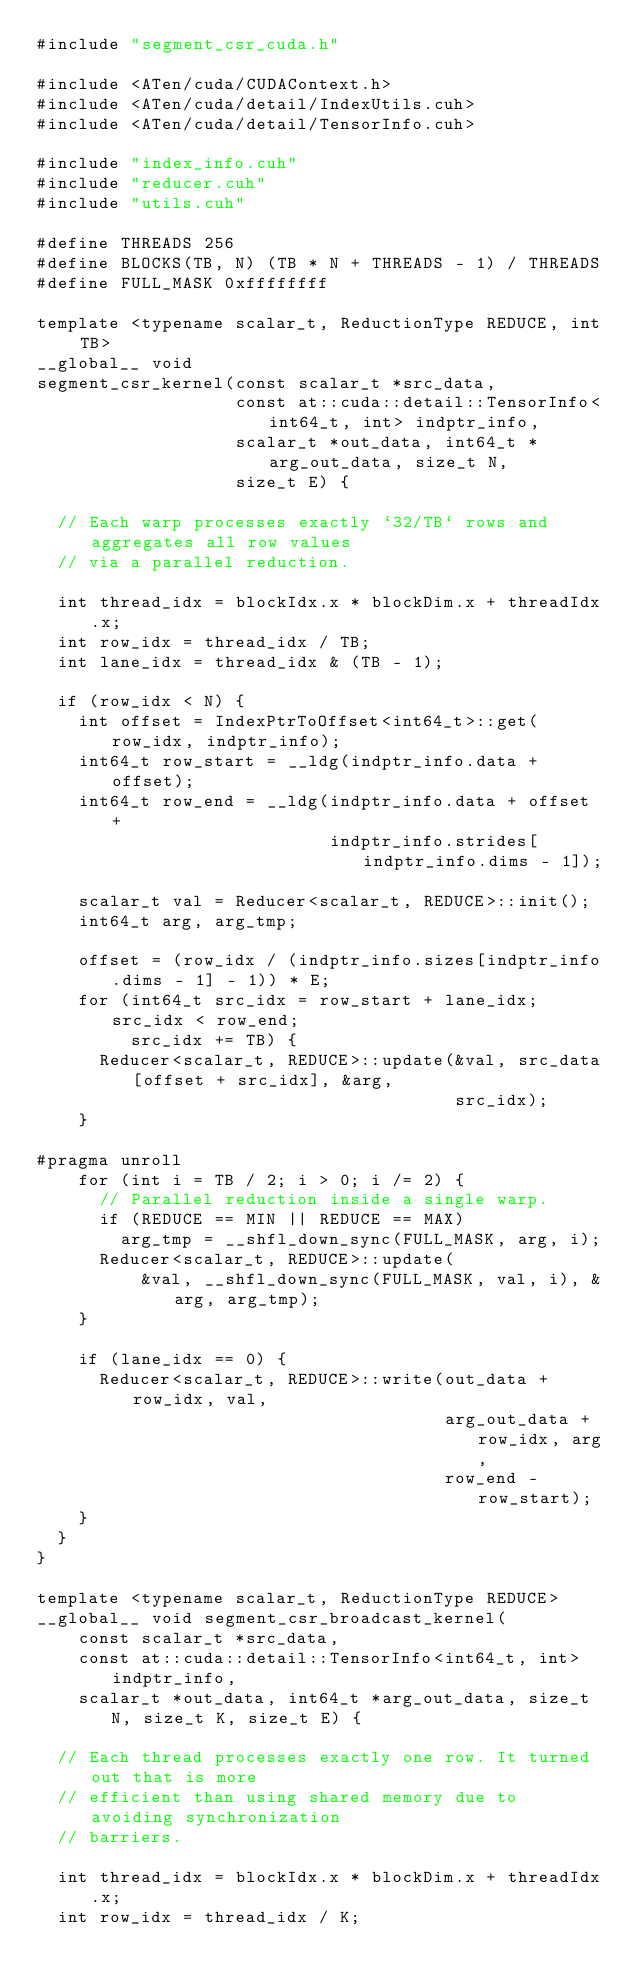<code> <loc_0><loc_0><loc_500><loc_500><_Cuda_>#include "segment_csr_cuda.h"

#include <ATen/cuda/CUDAContext.h>
#include <ATen/cuda/detail/IndexUtils.cuh>
#include <ATen/cuda/detail/TensorInfo.cuh>

#include "index_info.cuh"
#include "reducer.cuh"
#include "utils.cuh"

#define THREADS 256
#define BLOCKS(TB, N) (TB * N + THREADS - 1) / THREADS
#define FULL_MASK 0xffffffff

template <typename scalar_t, ReductionType REDUCE, int TB>
__global__ void
segment_csr_kernel(const scalar_t *src_data,
                   const at::cuda::detail::TensorInfo<int64_t, int> indptr_info,
                   scalar_t *out_data, int64_t *arg_out_data, size_t N,
                   size_t E) {

  // Each warp processes exactly `32/TB` rows and aggregates all row values
  // via a parallel reduction.

  int thread_idx = blockIdx.x * blockDim.x + threadIdx.x;
  int row_idx = thread_idx / TB;
  int lane_idx = thread_idx & (TB - 1);

  if (row_idx < N) {
    int offset = IndexPtrToOffset<int64_t>::get(row_idx, indptr_info);
    int64_t row_start = __ldg(indptr_info.data + offset);
    int64_t row_end = __ldg(indptr_info.data + offset +
                            indptr_info.strides[indptr_info.dims - 1]);

    scalar_t val = Reducer<scalar_t, REDUCE>::init();
    int64_t arg, arg_tmp;

    offset = (row_idx / (indptr_info.sizes[indptr_info.dims - 1] - 1)) * E;
    for (int64_t src_idx = row_start + lane_idx; src_idx < row_end;
         src_idx += TB) {
      Reducer<scalar_t, REDUCE>::update(&val, src_data[offset + src_idx], &arg,
                                        src_idx);
    }

#pragma unroll
    for (int i = TB / 2; i > 0; i /= 2) {
      // Parallel reduction inside a single warp.
      if (REDUCE == MIN || REDUCE == MAX)
        arg_tmp = __shfl_down_sync(FULL_MASK, arg, i);
      Reducer<scalar_t, REDUCE>::update(
          &val, __shfl_down_sync(FULL_MASK, val, i), &arg, arg_tmp);
    }

    if (lane_idx == 0) {
      Reducer<scalar_t, REDUCE>::write(out_data + row_idx, val,
                                       arg_out_data + row_idx, arg,
                                       row_end - row_start);
    }
  }
}

template <typename scalar_t, ReductionType REDUCE>
__global__ void segment_csr_broadcast_kernel(
    const scalar_t *src_data,
    const at::cuda::detail::TensorInfo<int64_t, int> indptr_info,
    scalar_t *out_data, int64_t *arg_out_data, size_t N, size_t K, size_t E) {

  // Each thread processes exactly one row. It turned out that is more
  // efficient than using shared memory due to avoiding synchronization
  // barriers.

  int thread_idx = blockIdx.x * blockDim.x + threadIdx.x;
  int row_idx = thread_idx / K;</code> 